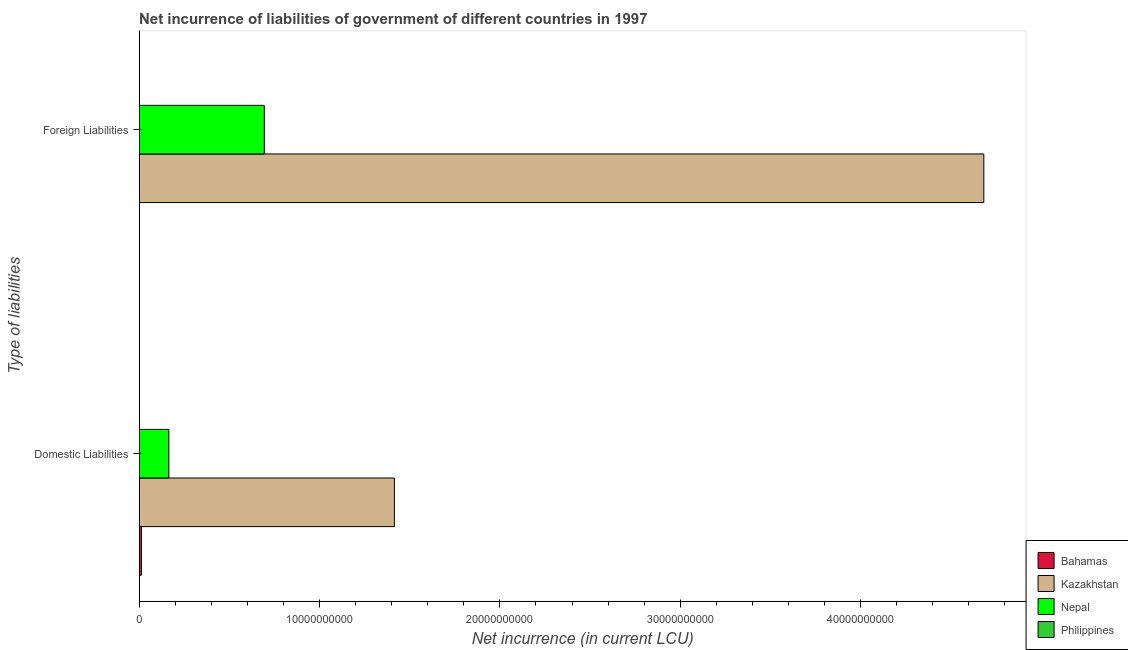How many bars are there on the 1st tick from the top?
Give a very brief answer. 3. What is the label of the 1st group of bars from the top?
Offer a very short reply. Foreign Liabilities. What is the net incurrence of foreign liabilities in Kazakhstan?
Make the answer very short. 4.68e+1. Across all countries, what is the maximum net incurrence of foreign liabilities?
Offer a very short reply. 4.68e+1. Across all countries, what is the minimum net incurrence of foreign liabilities?
Your answer should be very brief. 0. In which country was the net incurrence of foreign liabilities maximum?
Give a very brief answer. Kazakhstan. What is the total net incurrence of domestic liabilities in the graph?
Your answer should be compact. 1.59e+1. What is the difference between the net incurrence of foreign liabilities in Kazakhstan and that in Nepal?
Provide a succinct answer. 3.99e+1. What is the difference between the net incurrence of domestic liabilities in Philippines and the net incurrence of foreign liabilities in Kazakhstan?
Give a very brief answer. -4.68e+1. What is the average net incurrence of domestic liabilities per country?
Your answer should be very brief. 3.98e+09. What is the difference between the net incurrence of foreign liabilities and net incurrence of domestic liabilities in Kazakhstan?
Offer a terse response. 3.27e+1. What is the ratio of the net incurrence of domestic liabilities in Nepal to that in Kazakhstan?
Make the answer very short. 0.12. How many bars are there?
Ensure brevity in your answer.  6. Are all the bars in the graph horizontal?
Ensure brevity in your answer.  Yes. What is the difference between two consecutive major ticks on the X-axis?
Give a very brief answer. 1.00e+1. Does the graph contain grids?
Keep it short and to the point. No. How many legend labels are there?
Provide a succinct answer. 4. What is the title of the graph?
Ensure brevity in your answer.  Net incurrence of liabilities of government of different countries in 1997. What is the label or title of the X-axis?
Make the answer very short. Net incurrence (in current LCU). What is the label or title of the Y-axis?
Keep it short and to the point. Type of liabilities. What is the Net incurrence (in current LCU) in Bahamas in Domestic Liabilities?
Provide a succinct answer. 1.33e+08. What is the Net incurrence (in current LCU) in Kazakhstan in Domestic Liabilities?
Your answer should be very brief. 1.42e+1. What is the Net incurrence (in current LCU) of Nepal in Domestic Liabilities?
Offer a very short reply. 1.65e+09. What is the Net incurrence (in current LCU) in Bahamas in Foreign Liabilities?
Offer a terse response. 1.71e+07. What is the Net incurrence (in current LCU) of Kazakhstan in Foreign Liabilities?
Offer a terse response. 4.68e+1. What is the Net incurrence (in current LCU) in Nepal in Foreign Liabilities?
Give a very brief answer. 6.94e+09. What is the Net incurrence (in current LCU) of Philippines in Foreign Liabilities?
Your answer should be very brief. 0. Across all Type of liabilities, what is the maximum Net incurrence (in current LCU) of Bahamas?
Your response must be concise. 1.33e+08. Across all Type of liabilities, what is the maximum Net incurrence (in current LCU) of Kazakhstan?
Give a very brief answer. 4.68e+1. Across all Type of liabilities, what is the maximum Net incurrence (in current LCU) of Nepal?
Make the answer very short. 6.94e+09. Across all Type of liabilities, what is the minimum Net incurrence (in current LCU) in Bahamas?
Make the answer very short. 1.71e+07. Across all Type of liabilities, what is the minimum Net incurrence (in current LCU) in Kazakhstan?
Offer a terse response. 1.42e+1. Across all Type of liabilities, what is the minimum Net incurrence (in current LCU) in Nepal?
Make the answer very short. 1.65e+09. What is the total Net incurrence (in current LCU) in Bahamas in the graph?
Your answer should be very brief. 1.50e+08. What is the total Net incurrence (in current LCU) of Kazakhstan in the graph?
Provide a short and direct response. 6.10e+1. What is the total Net incurrence (in current LCU) of Nepal in the graph?
Your answer should be compact. 8.59e+09. What is the total Net incurrence (in current LCU) in Philippines in the graph?
Offer a very short reply. 0. What is the difference between the Net incurrence (in current LCU) of Bahamas in Domestic Liabilities and that in Foreign Liabilities?
Your answer should be very brief. 1.15e+08. What is the difference between the Net incurrence (in current LCU) of Kazakhstan in Domestic Liabilities and that in Foreign Liabilities?
Keep it short and to the point. -3.27e+1. What is the difference between the Net incurrence (in current LCU) of Nepal in Domestic Liabilities and that in Foreign Liabilities?
Your response must be concise. -5.29e+09. What is the difference between the Net incurrence (in current LCU) in Bahamas in Domestic Liabilities and the Net incurrence (in current LCU) in Kazakhstan in Foreign Liabilities?
Offer a terse response. -4.67e+1. What is the difference between the Net incurrence (in current LCU) in Bahamas in Domestic Liabilities and the Net incurrence (in current LCU) in Nepal in Foreign Liabilities?
Make the answer very short. -6.81e+09. What is the difference between the Net incurrence (in current LCU) of Kazakhstan in Domestic Liabilities and the Net incurrence (in current LCU) of Nepal in Foreign Liabilities?
Offer a very short reply. 7.21e+09. What is the average Net incurrence (in current LCU) in Bahamas per Type of liabilities?
Your answer should be compact. 7.48e+07. What is the average Net incurrence (in current LCU) of Kazakhstan per Type of liabilities?
Make the answer very short. 3.05e+1. What is the average Net incurrence (in current LCU) of Nepal per Type of liabilities?
Make the answer very short. 4.30e+09. What is the difference between the Net incurrence (in current LCU) in Bahamas and Net incurrence (in current LCU) in Kazakhstan in Domestic Liabilities?
Your answer should be compact. -1.40e+1. What is the difference between the Net incurrence (in current LCU) of Bahamas and Net incurrence (in current LCU) of Nepal in Domestic Liabilities?
Your answer should be compact. -1.52e+09. What is the difference between the Net incurrence (in current LCU) in Kazakhstan and Net incurrence (in current LCU) in Nepal in Domestic Liabilities?
Offer a terse response. 1.25e+1. What is the difference between the Net incurrence (in current LCU) in Bahamas and Net incurrence (in current LCU) in Kazakhstan in Foreign Liabilities?
Make the answer very short. -4.68e+1. What is the difference between the Net incurrence (in current LCU) of Bahamas and Net incurrence (in current LCU) of Nepal in Foreign Liabilities?
Your answer should be compact. -6.92e+09. What is the difference between the Net incurrence (in current LCU) in Kazakhstan and Net incurrence (in current LCU) in Nepal in Foreign Liabilities?
Your response must be concise. 3.99e+1. What is the ratio of the Net incurrence (in current LCU) of Bahamas in Domestic Liabilities to that in Foreign Liabilities?
Make the answer very short. 7.76. What is the ratio of the Net incurrence (in current LCU) of Kazakhstan in Domestic Liabilities to that in Foreign Liabilities?
Give a very brief answer. 0.3. What is the ratio of the Net incurrence (in current LCU) in Nepal in Domestic Liabilities to that in Foreign Liabilities?
Provide a short and direct response. 0.24. What is the difference between the highest and the second highest Net incurrence (in current LCU) in Bahamas?
Make the answer very short. 1.15e+08. What is the difference between the highest and the second highest Net incurrence (in current LCU) of Kazakhstan?
Your answer should be compact. 3.27e+1. What is the difference between the highest and the second highest Net incurrence (in current LCU) of Nepal?
Keep it short and to the point. 5.29e+09. What is the difference between the highest and the lowest Net incurrence (in current LCU) of Bahamas?
Offer a terse response. 1.15e+08. What is the difference between the highest and the lowest Net incurrence (in current LCU) of Kazakhstan?
Your response must be concise. 3.27e+1. What is the difference between the highest and the lowest Net incurrence (in current LCU) of Nepal?
Your answer should be compact. 5.29e+09. 